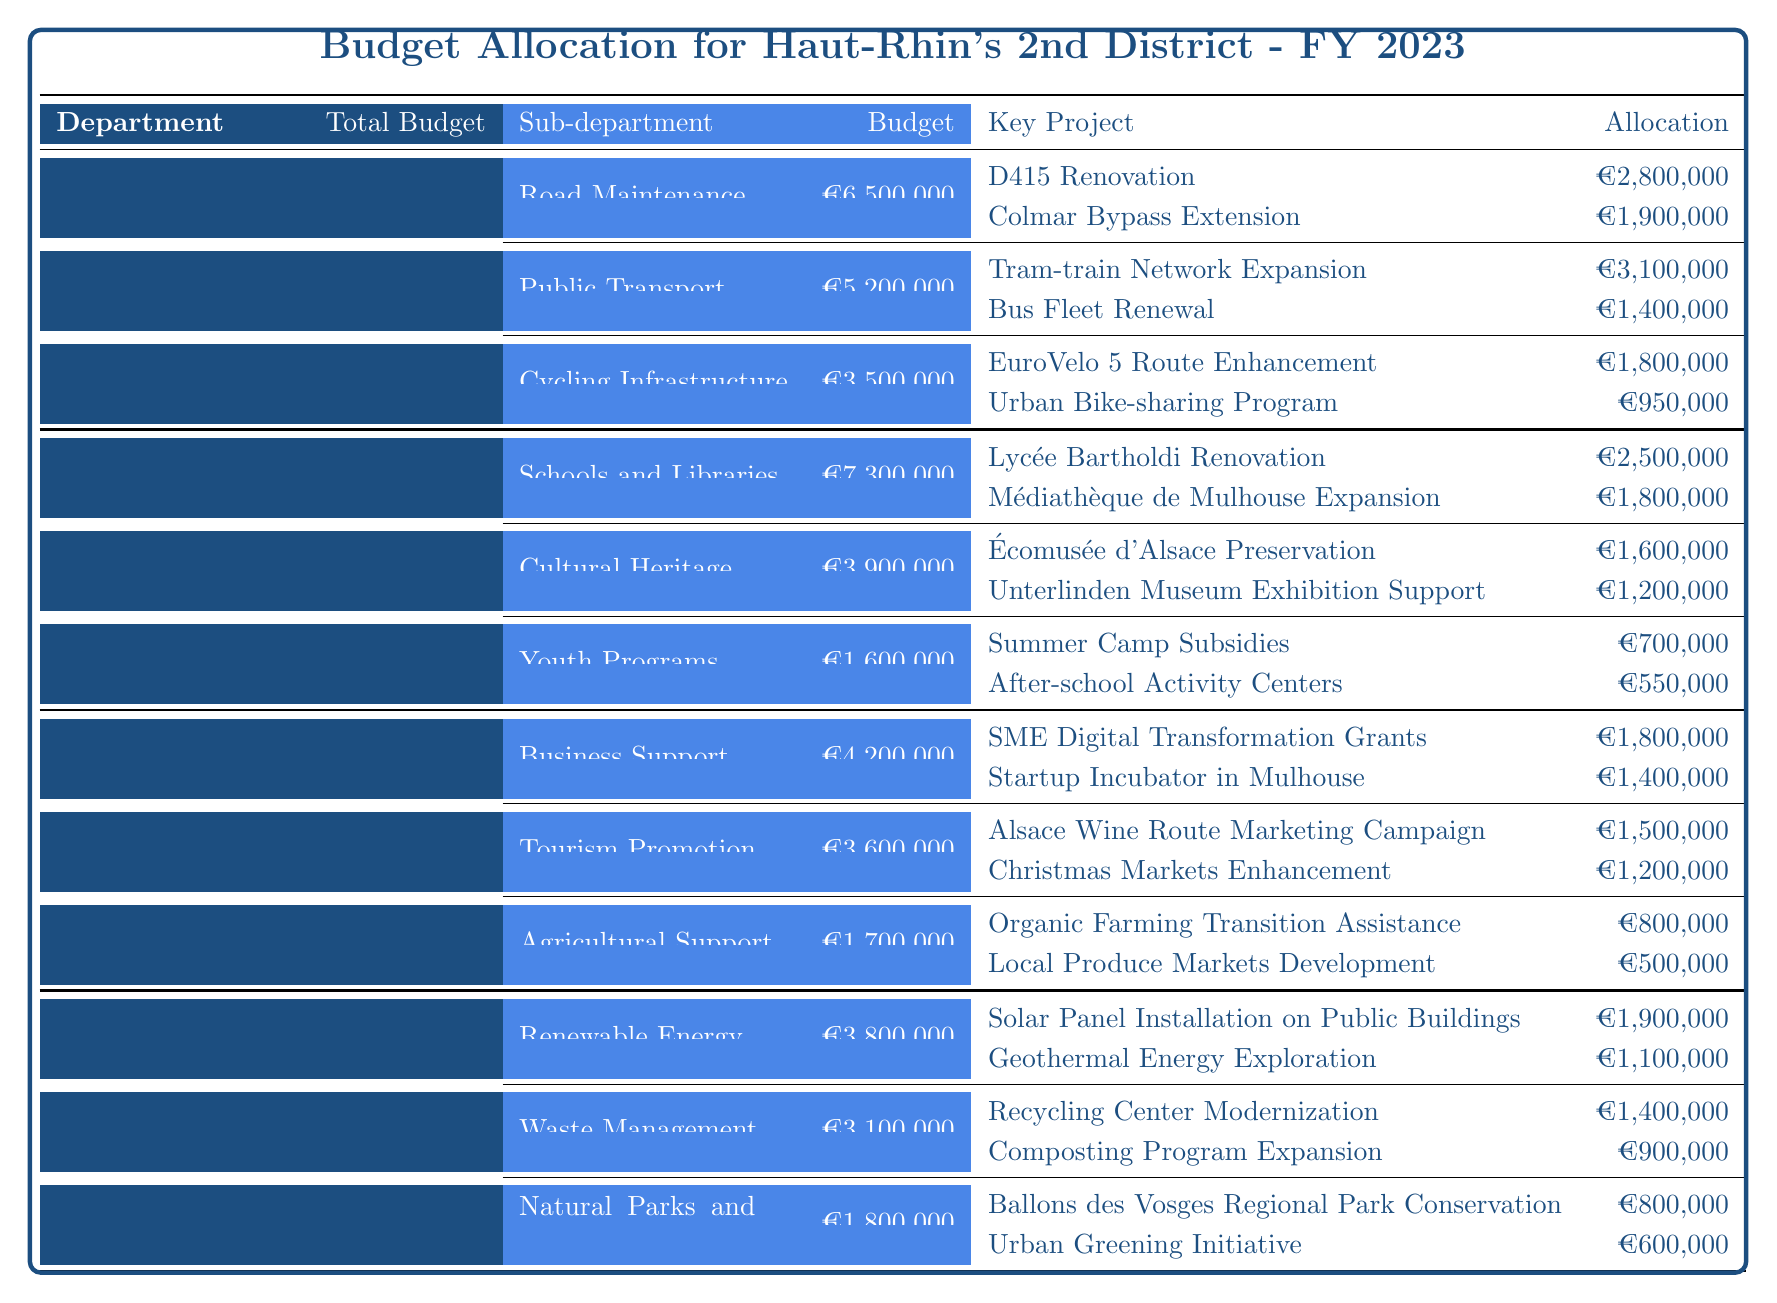What is the total budget for the Environment and Sustainability department? The table shows that the total budget for the Environment and Sustainability department is listed under the corresponding header. By referring to the total budget column, we find it to be €8,700,000.
Answer: €8,700,000 Which sub-department of Education and Culture has the highest budget? The sub-departments listed under Education and Culture include Schools and Libraries (€7,300,000), Cultural Heritage (€3,900,000), and Youth Programs (€1,600,000). The highest is Schools and Libraries.
Answer: Schools and Libraries What percentage of the total budget for Infrastructure and Transport is allocated to Road Maintenance? The total budget for Infrastructure and Transport is €15,200,000 and Road Maintenance has €6,500,000 allocated. To find the percentage, we calculate (€6,500,000 / €15,200,000) * 100 = 42.76%.
Answer: 42.76% Is the budget for Agricultural Support greater than that of Waste Management? The Agricultural Support budget is €1,700,000 whereas the Waste Management budget is €3,100,000. Comparing these values shows that €1,700,000 is less than €3,100,000. Thus, Agricultural Support is not greater.
Answer: No What is the total allocation for key projects in Tourism Promotion? In the Tourism Promotion sub-department, the key projects are Alsace Wine Route Marketing Campaign (€1,500,000) and Christmas Markets Enhancement (€1,200,000). The total allocation can be found by adding these two amounts: €1,500,000 + €1,200,000 = €2,700,000.
Answer: €2,700,000 Which department received the lowest total budget? By examining the total budgets across all departments, Infrastructure and Transport (€15,200,000), Education and Culture (€12,800,000), Economic Development (€9,500,000), and Environment and Sustainability (€8,700,000) are listed. The lowest is Environment and Sustainability.
Answer: Environment and Sustainability How much is allocated for the Tram-train Network Expansion project under Public Transport? Looking in the Public Transport sub-department, the Tram-train Network Expansion project is listed with an allocation of €3,100,000.
Answer: €3,100,000 What is the difference in total budget between the Education and Culture department and the Economic Development department? The total budget for Education and Culture is €12,800,000 and for Economic Development, it is €9,500,000. The difference is calculated as €12,800,000 - €9,500,000 = €3,300,000.
Answer: €3,300,000 Which key project in Cycling Infrastructure received the least funding? In the Cycling Infrastructure sub-department, the key projects are EuroVelo 5 Route Enhancement (€1,800,000) and Urban Bike-sharing Program (€950,000). The least funding is for the Urban Bike-sharing Program.
Answer: Urban Bike-sharing Program What is the total budget allocation for all sub-departments under the Economic Development department? The total budget for the Economic Development department encompasses Business Support (€4,200,000), Tourism Promotion (€3,600,000), and Agricultural Support (€1,700,000). Adding these gives us €4,200,000 + €3,600,000 + €1,700,000 = €9,500,000.
Answer: €9,500,000 